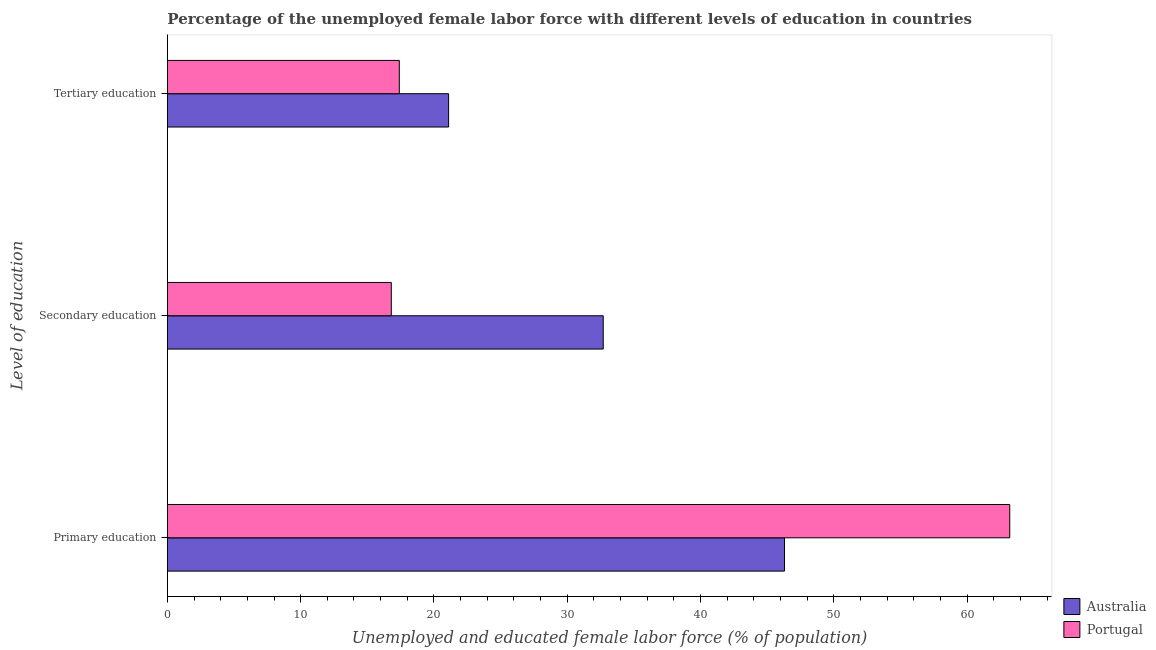How many different coloured bars are there?
Give a very brief answer. 2. Are the number of bars per tick equal to the number of legend labels?
Offer a very short reply. Yes. Are the number of bars on each tick of the Y-axis equal?
Give a very brief answer. Yes. What is the label of the 3rd group of bars from the top?
Make the answer very short. Primary education. What is the percentage of female labor force who received primary education in Australia?
Offer a terse response. 46.3. Across all countries, what is the maximum percentage of female labor force who received secondary education?
Keep it short and to the point. 32.7. Across all countries, what is the minimum percentage of female labor force who received primary education?
Make the answer very short. 46.3. In which country was the percentage of female labor force who received tertiary education maximum?
Offer a terse response. Australia. What is the total percentage of female labor force who received tertiary education in the graph?
Your answer should be compact. 38.5. What is the difference between the percentage of female labor force who received tertiary education in Australia and that in Portugal?
Your response must be concise. 3.7. What is the difference between the percentage of female labor force who received primary education in Portugal and the percentage of female labor force who received tertiary education in Australia?
Your answer should be compact. 42.1. What is the average percentage of female labor force who received tertiary education per country?
Your response must be concise. 19.25. What is the difference between the percentage of female labor force who received tertiary education and percentage of female labor force who received secondary education in Portugal?
Provide a short and direct response. 0.6. What is the ratio of the percentage of female labor force who received primary education in Portugal to that in Australia?
Offer a terse response. 1.37. Is the difference between the percentage of female labor force who received tertiary education in Australia and Portugal greater than the difference between the percentage of female labor force who received primary education in Australia and Portugal?
Offer a very short reply. Yes. What is the difference between the highest and the second highest percentage of female labor force who received secondary education?
Offer a terse response. 15.9. What is the difference between the highest and the lowest percentage of female labor force who received tertiary education?
Your response must be concise. 3.7. What does the 2nd bar from the top in Tertiary education represents?
Your answer should be very brief. Australia. What does the 2nd bar from the bottom in Tertiary education represents?
Offer a very short reply. Portugal. Is it the case that in every country, the sum of the percentage of female labor force who received primary education and percentage of female labor force who received secondary education is greater than the percentage of female labor force who received tertiary education?
Offer a terse response. Yes. Are all the bars in the graph horizontal?
Offer a terse response. Yes. Does the graph contain grids?
Provide a succinct answer. No. Where does the legend appear in the graph?
Offer a very short reply. Bottom right. What is the title of the graph?
Give a very brief answer. Percentage of the unemployed female labor force with different levels of education in countries. Does "China" appear as one of the legend labels in the graph?
Your answer should be very brief. No. What is the label or title of the X-axis?
Make the answer very short. Unemployed and educated female labor force (% of population). What is the label or title of the Y-axis?
Provide a succinct answer. Level of education. What is the Unemployed and educated female labor force (% of population) in Australia in Primary education?
Offer a terse response. 46.3. What is the Unemployed and educated female labor force (% of population) in Portugal in Primary education?
Ensure brevity in your answer.  63.2. What is the Unemployed and educated female labor force (% of population) in Australia in Secondary education?
Keep it short and to the point. 32.7. What is the Unemployed and educated female labor force (% of population) of Portugal in Secondary education?
Provide a succinct answer. 16.8. What is the Unemployed and educated female labor force (% of population) of Australia in Tertiary education?
Provide a short and direct response. 21.1. What is the Unemployed and educated female labor force (% of population) in Portugal in Tertiary education?
Offer a terse response. 17.4. Across all Level of education, what is the maximum Unemployed and educated female labor force (% of population) in Australia?
Offer a very short reply. 46.3. Across all Level of education, what is the maximum Unemployed and educated female labor force (% of population) of Portugal?
Keep it short and to the point. 63.2. Across all Level of education, what is the minimum Unemployed and educated female labor force (% of population) in Australia?
Provide a short and direct response. 21.1. Across all Level of education, what is the minimum Unemployed and educated female labor force (% of population) of Portugal?
Your answer should be compact. 16.8. What is the total Unemployed and educated female labor force (% of population) in Australia in the graph?
Offer a terse response. 100.1. What is the total Unemployed and educated female labor force (% of population) in Portugal in the graph?
Keep it short and to the point. 97.4. What is the difference between the Unemployed and educated female labor force (% of population) of Portugal in Primary education and that in Secondary education?
Keep it short and to the point. 46.4. What is the difference between the Unemployed and educated female labor force (% of population) of Australia in Primary education and that in Tertiary education?
Ensure brevity in your answer.  25.2. What is the difference between the Unemployed and educated female labor force (% of population) of Portugal in Primary education and that in Tertiary education?
Ensure brevity in your answer.  45.8. What is the difference between the Unemployed and educated female labor force (% of population) in Australia in Primary education and the Unemployed and educated female labor force (% of population) in Portugal in Secondary education?
Your answer should be compact. 29.5. What is the difference between the Unemployed and educated female labor force (% of population) of Australia in Primary education and the Unemployed and educated female labor force (% of population) of Portugal in Tertiary education?
Keep it short and to the point. 28.9. What is the difference between the Unemployed and educated female labor force (% of population) of Australia in Secondary education and the Unemployed and educated female labor force (% of population) of Portugal in Tertiary education?
Provide a succinct answer. 15.3. What is the average Unemployed and educated female labor force (% of population) in Australia per Level of education?
Keep it short and to the point. 33.37. What is the average Unemployed and educated female labor force (% of population) of Portugal per Level of education?
Make the answer very short. 32.47. What is the difference between the Unemployed and educated female labor force (% of population) in Australia and Unemployed and educated female labor force (% of population) in Portugal in Primary education?
Ensure brevity in your answer.  -16.9. What is the ratio of the Unemployed and educated female labor force (% of population) in Australia in Primary education to that in Secondary education?
Your answer should be compact. 1.42. What is the ratio of the Unemployed and educated female labor force (% of population) of Portugal in Primary education to that in Secondary education?
Your answer should be very brief. 3.76. What is the ratio of the Unemployed and educated female labor force (% of population) of Australia in Primary education to that in Tertiary education?
Provide a short and direct response. 2.19. What is the ratio of the Unemployed and educated female labor force (% of population) in Portugal in Primary education to that in Tertiary education?
Provide a succinct answer. 3.63. What is the ratio of the Unemployed and educated female labor force (% of population) of Australia in Secondary education to that in Tertiary education?
Ensure brevity in your answer.  1.55. What is the ratio of the Unemployed and educated female labor force (% of population) in Portugal in Secondary education to that in Tertiary education?
Make the answer very short. 0.97. What is the difference between the highest and the second highest Unemployed and educated female labor force (% of population) in Portugal?
Your answer should be very brief. 45.8. What is the difference between the highest and the lowest Unemployed and educated female labor force (% of population) in Australia?
Your response must be concise. 25.2. What is the difference between the highest and the lowest Unemployed and educated female labor force (% of population) of Portugal?
Provide a succinct answer. 46.4. 